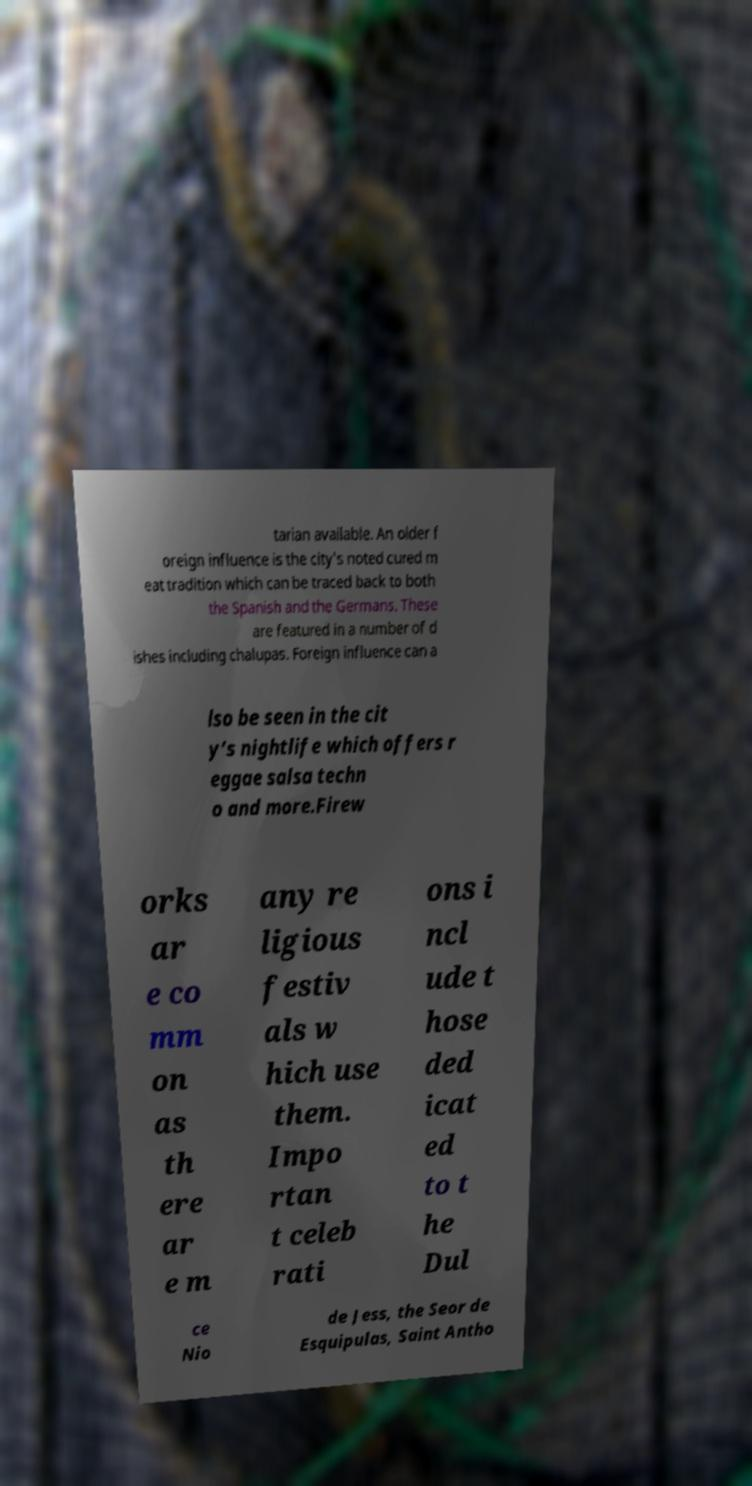Can you read and provide the text displayed in the image?This photo seems to have some interesting text. Can you extract and type it out for me? tarian available. An older f oreign influence is the city’s noted cured m eat tradition which can be traced back to both the Spanish and the Germans. These are featured in a number of d ishes including chalupas. Foreign influence can a lso be seen in the cit y’s nightlife which offers r eggae salsa techn o and more.Firew orks ar e co mm on as th ere ar e m any re ligious festiv als w hich use them. Impo rtan t celeb rati ons i ncl ude t hose ded icat ed to t he Dul ce Nio de Jess, the Seor de Esquipulas, Saint Antho 